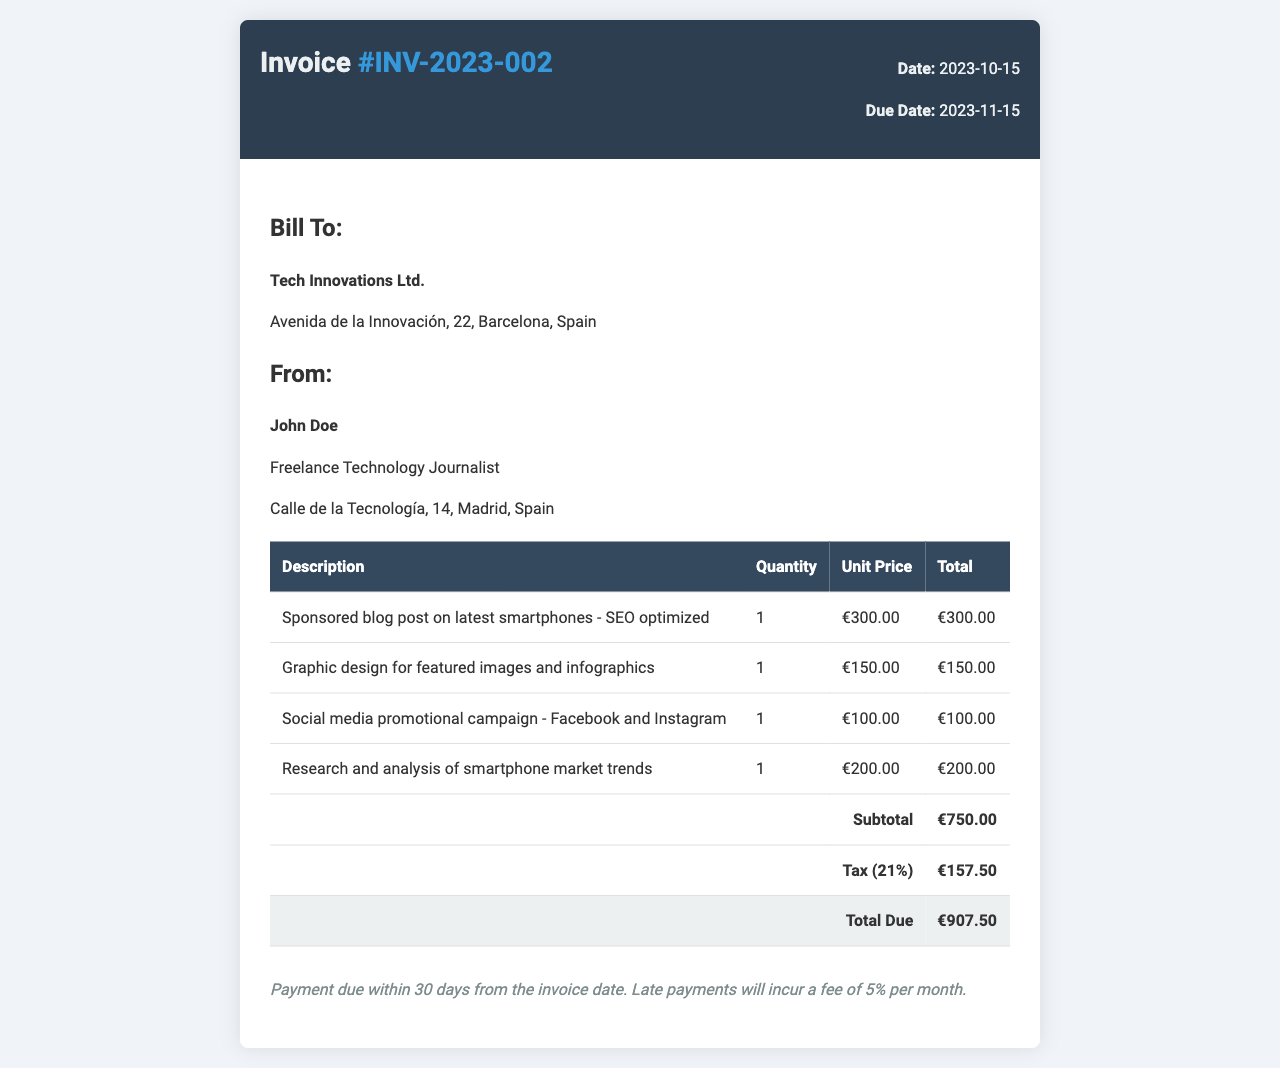What is the invoice number? The invoice number is clearly stated in the title of the document.
Answer: #INV-2023-002 What is the total amount due? The total amount due is indicated in the total row at the bottom of the invoice.
Answer: €907.50 Who is the freelancer? The name of the freelancer is provided in the "From" section of the invoice.
Answer: John Doe What is the due date for this invoice? The due date is specified in the invoice details near the title.
Answer: 2023-11-15 What percentage is the tax applied? The tax rate is mentioned alongside the tax entry within the table.
Answer: 21% How much is charged for the graphic design? The amount for graphic design can be found in the details of the service row in the invoice.
Answer: €150.00 What service is billed for research and analysis? The specific service is described in the corresponding row of the invoice table.
Answer: Research and analysis of smartphone market trends What is the subtotal before tax? The subtotal amount is clearly indicated in the invoice table under the subtotal line.
Answer: €750.00 What is the payment term for this invoice? The payment terms are provided in a separate section at the bottom of the invoice.
Answer: Payment due within 30 days 